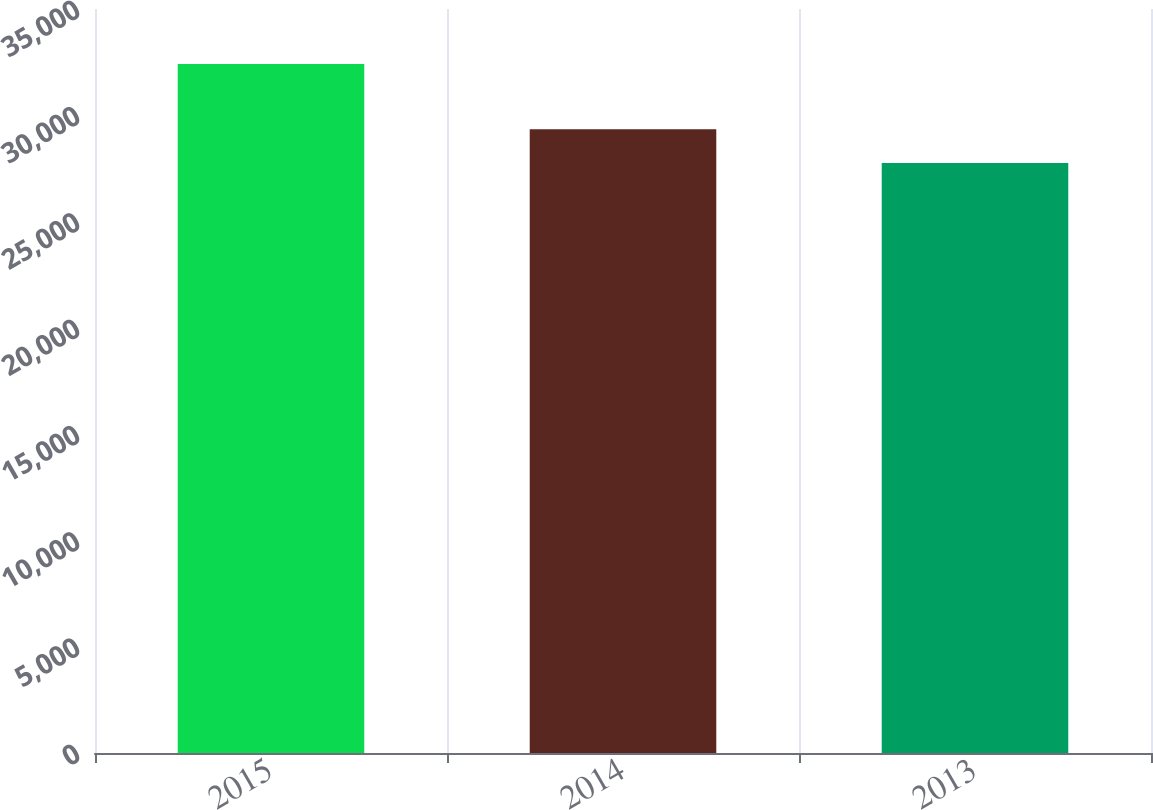Convert chart. <chart><loc_0><loc_0><loc_500><loc_500><bar_chart><fcel>2015<fcel>2014<fcel>2013<nl><fcel>32412<fcel>29340<fcel>27757<nl></chart> 